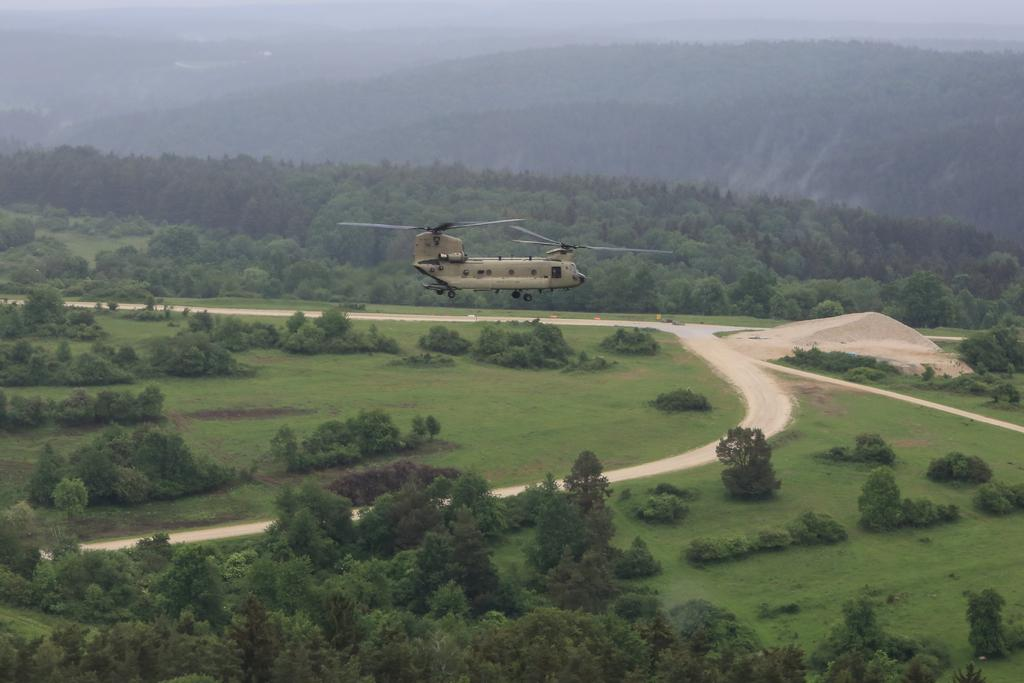What is flying in the image? There is a helicopter flying in the image. What type of natural environment can be seen in the image? There are trees and hills visible in the image. What type of string is being used to power the helicopter in the image? There is no string present in the image, and helicopters are not powered by strings. 